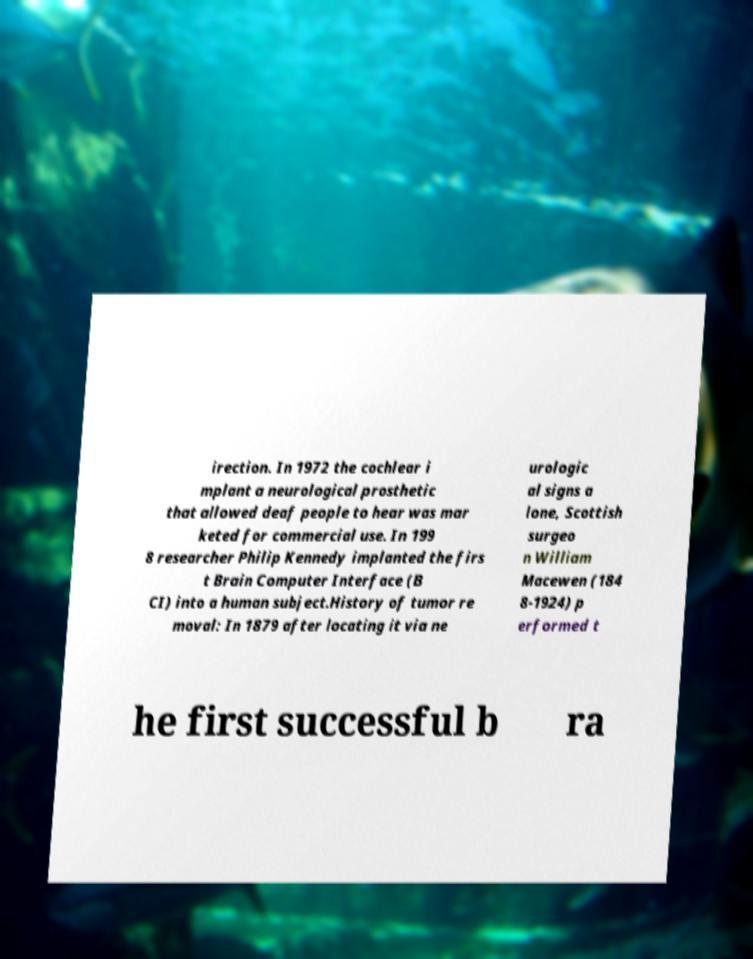Could you extract and type out the text from this image? irection. In 1972 the cochlear i mplant a neurological prosthetic that allowed deaf people to hear was mar keted for commercial use. In 199 8 researcher Philip Kennedy implanted the firs t Brain Computer Interface (B CI) into a human subject.History of tumor re moval: In 1879 after locating it via ne urologic al signs a lone, Scottish surgeo n William Macewen (184 8-1924) p erformed t he first successful b ra 